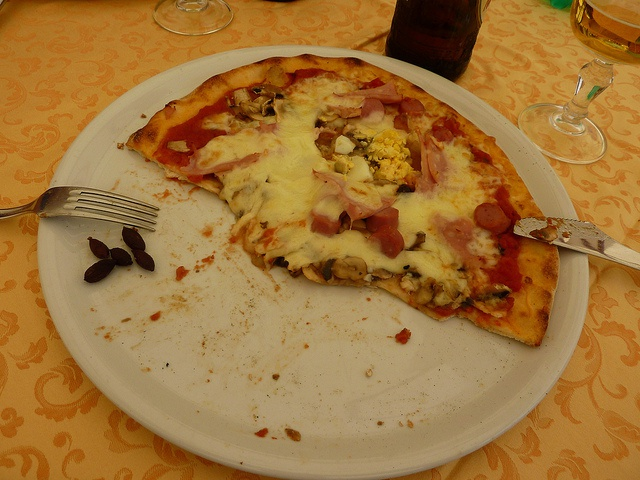Describe the objects in this image and their specific colors. I can see dining table in tan, olive, orange, and maroon tones, wine glass in olive, orange, tan, and maroon tones, bottle in olive, black, and maroon tones, knife in olive, tan, and maroon tones, and fork in olive, tan, maroon, and black tones in this image. 